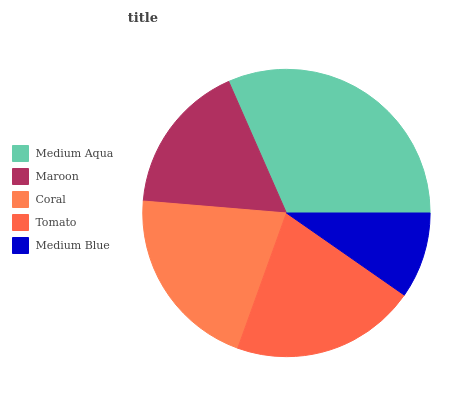Is Medium Blue the minimum?
Answer yes or no. Yes. Is Medium Aqua the maximum?
Answer yes or no. Yes. Is Maroon the minimum?
Answer yes or no. No. Is Maroon the maximum?
Answer yes or no. No. Is Medium Aqua greater than Maroon?
Answer yes or no. Yes. Is Maroon less than Medium Aqua?
Answer yes or no. Yes. Is Maroon greater than Medium Aqua?
Answer yes or no. No. Is Medium Aqua less than Maroon?
Answer yes or no. No. Is Tomato the high median?
Answer yes or no. Yes. Is Tomato the low median?
Answer yes or no. Yes. Is Maroon the high median?
Answer yes or no. No. Is Medium Aqua the low median?
Answer yes or no. No. 